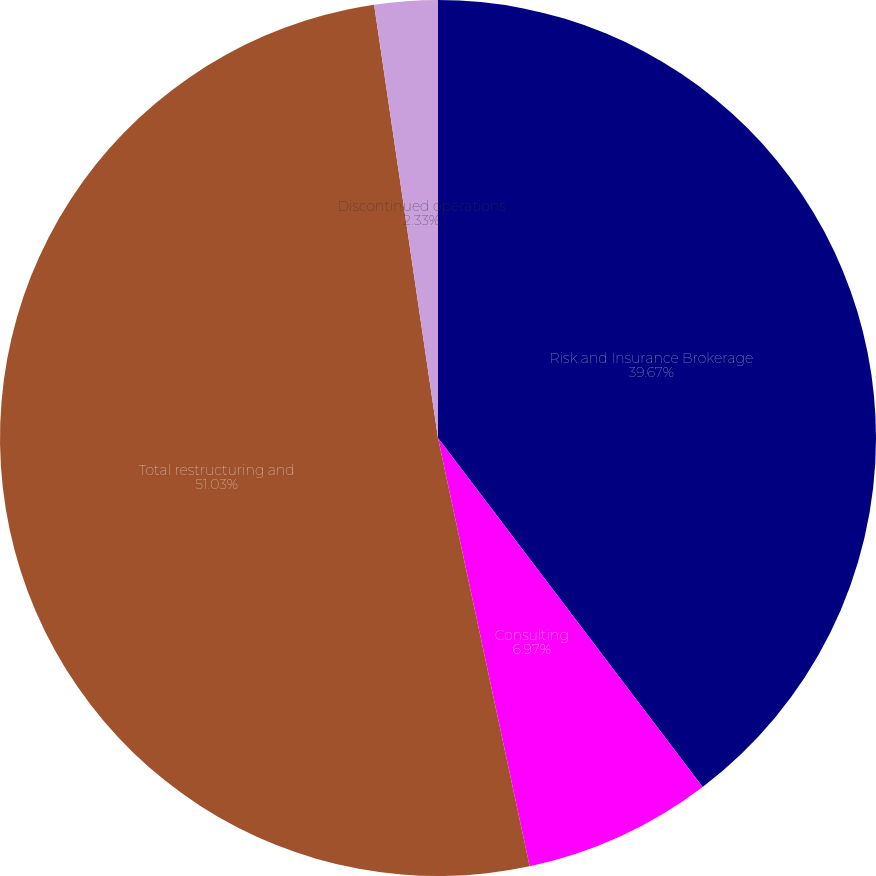<chart> <loc_0><loc_0><loc_500><loc_500><pie_chart><fcel>Risk and Insurance Brokerage<fcel>Consulting<fcel>Total restructuring and<fcel>Discontinued operations<nl><fcel>39.67%<fcel>6.97%<fcel>51.02%<fcel>2.33%<nl></chart> 